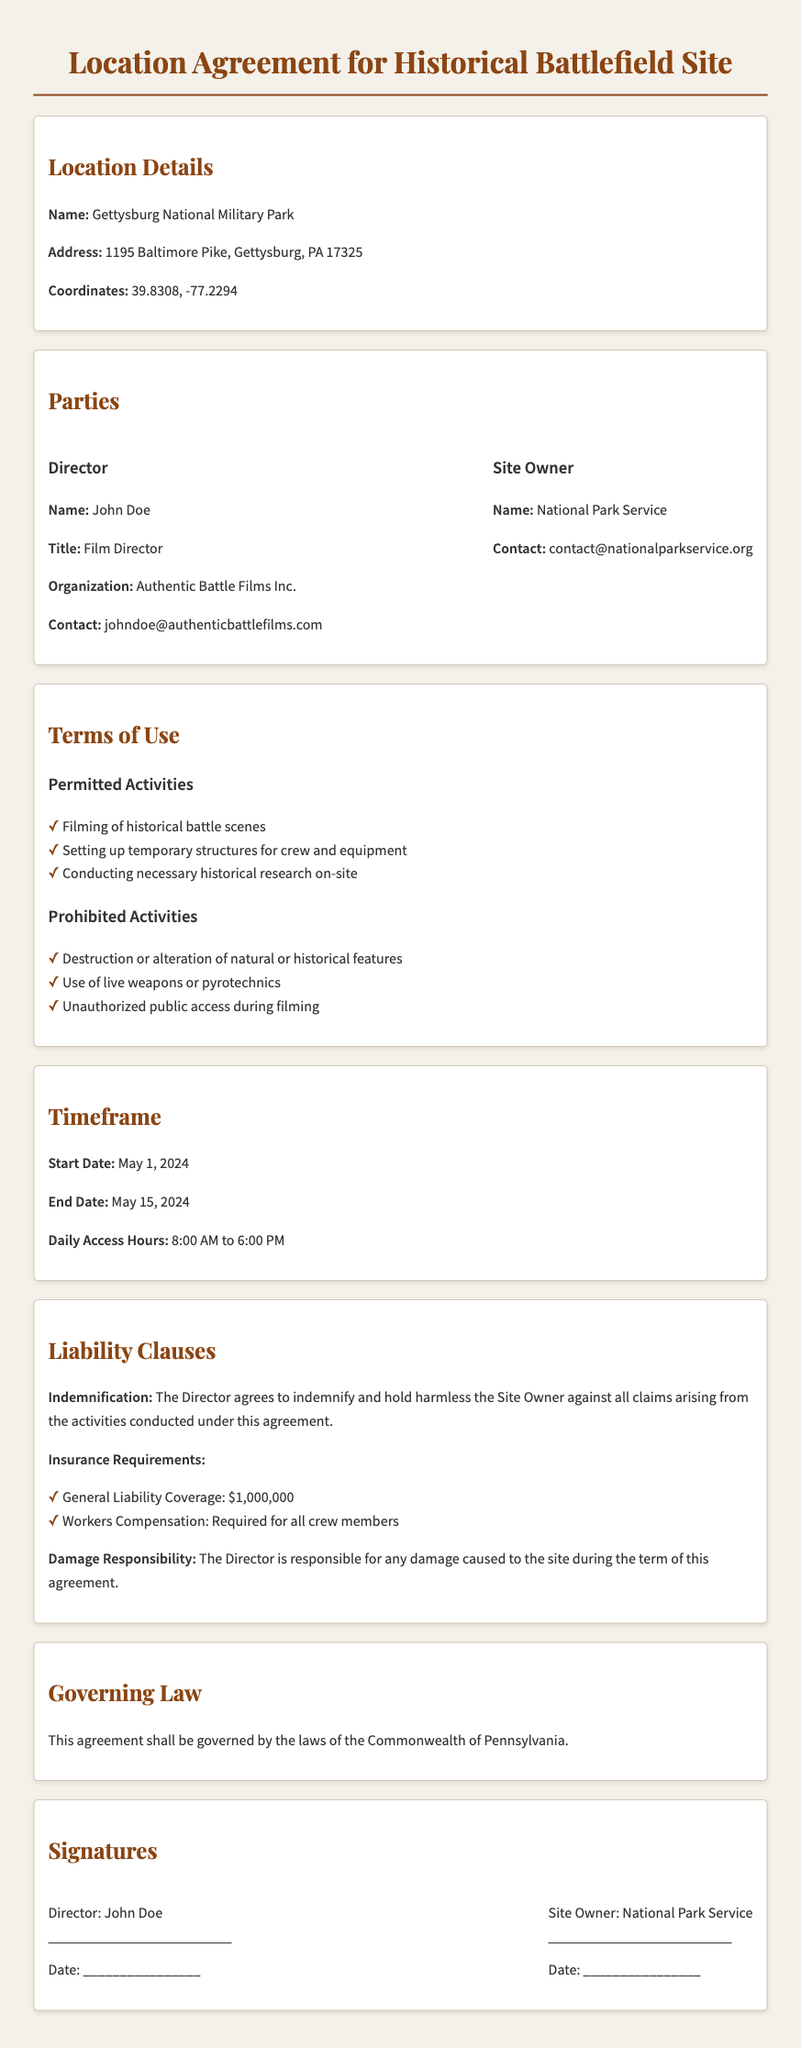What is the name of the location? The name of the location is mentioned in the section "Location Details."
Answer: Gettysburg National Military Park What are the start and end dates of the agreement? The start and end dates are provided in the "Timeframe" section.
Answer: May 1, 2024 to May 15, 2024 What is the daily access hour specified in the agreement? The daily access hours are listed under the "Timeframe" section.
Answer: 8:00 AM to 6:00 PM Who is the Director named in the document? The document specifies the Director's name in the "Parties" section.
Answer: John Doe What is the insurance requirement for general liability coverage? The amount for general liability coverage is mentioned in the "Liability Clauses" section.
Answer: $1,000,000 What is prohibited during filming according to the terms? The prohibited activity is listed under "Prohibited Activities."
Answer: Use of live weapons or pyrotechnics Which organization owns the site? The owner's organization is stated in the "Parties" section.
Answer: National Park Service What is the governing law stated in the agreement? The governing law is specified in its own section.
Answer: The laws of the Commonwealth of Pennsylvania What must the Director do regarding damage responsibility? The document outlines the responsibility in the "Liability Clauses" section.
Answer: The Director is responsible for any damage caused to the site 